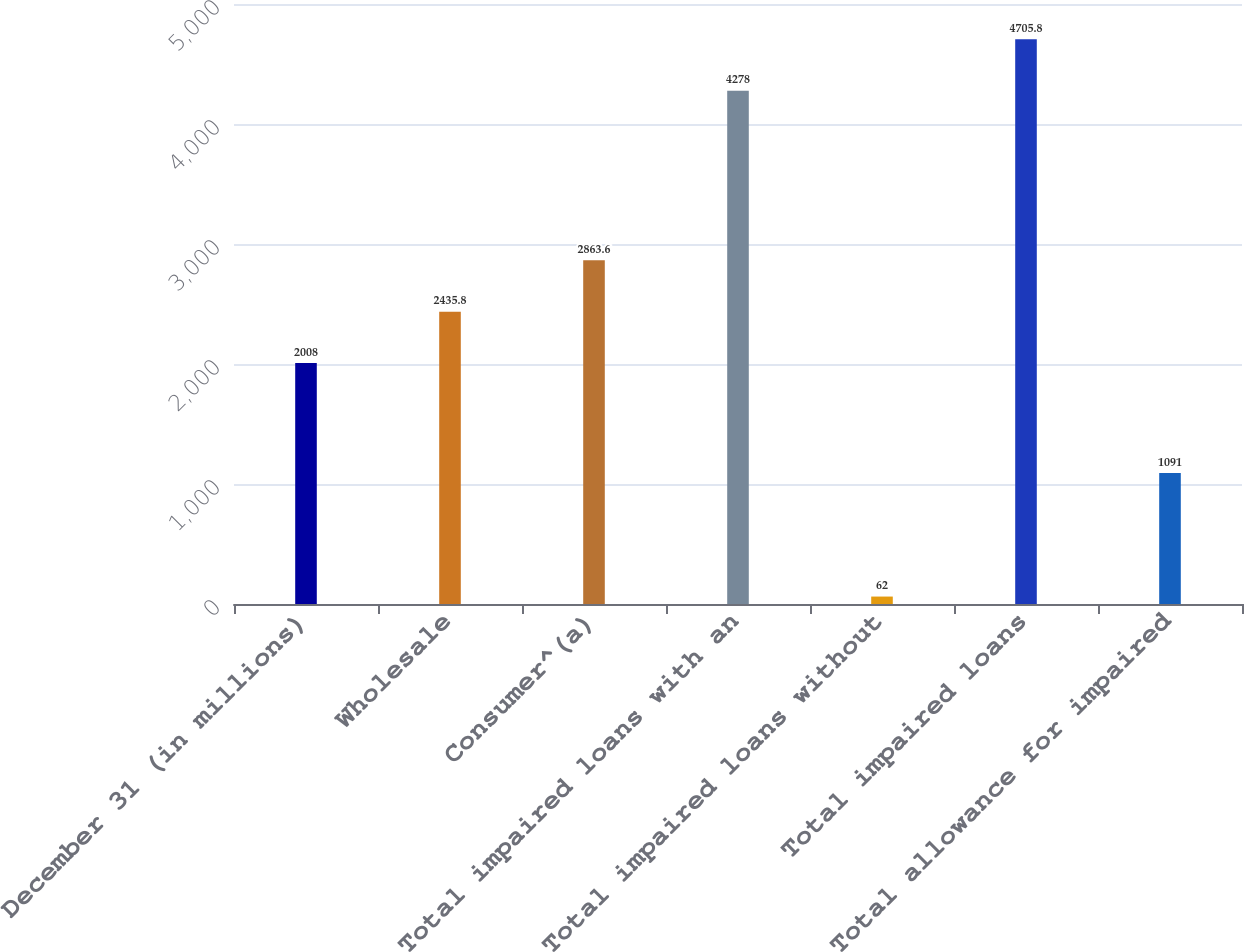<chart> <loc_0><loc_0><loc_500><loc_500><bar_chart><fcel>December 31 (in millions)<fcel>Wholesale<fcel>Consumer^(a)<fcel>Total impaired loans with an<fcel>Total impaired loans without<fcel>Total impaired loans<fcel>Total allowance for impaired<nl><fcel>2008<fcel>2435.8<fcel>2863.6<fcel>4278<fcel>62<fcel>4705.8<fcel>1091<nl></chart> 